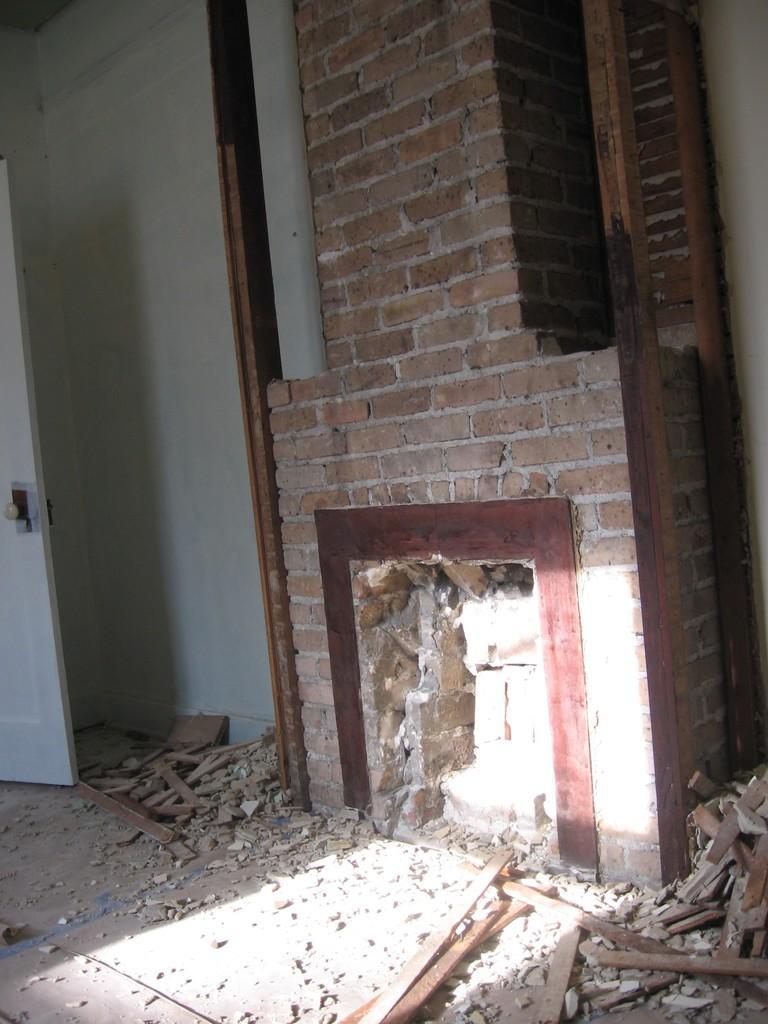How would you summarize this image in a sentence or two? In this image there is a brick wall in the middle. Beside the brick wall there are wooden sticks. At the bottom there are broken pieces of bricks and wooden stick. On the left side there is a door. 